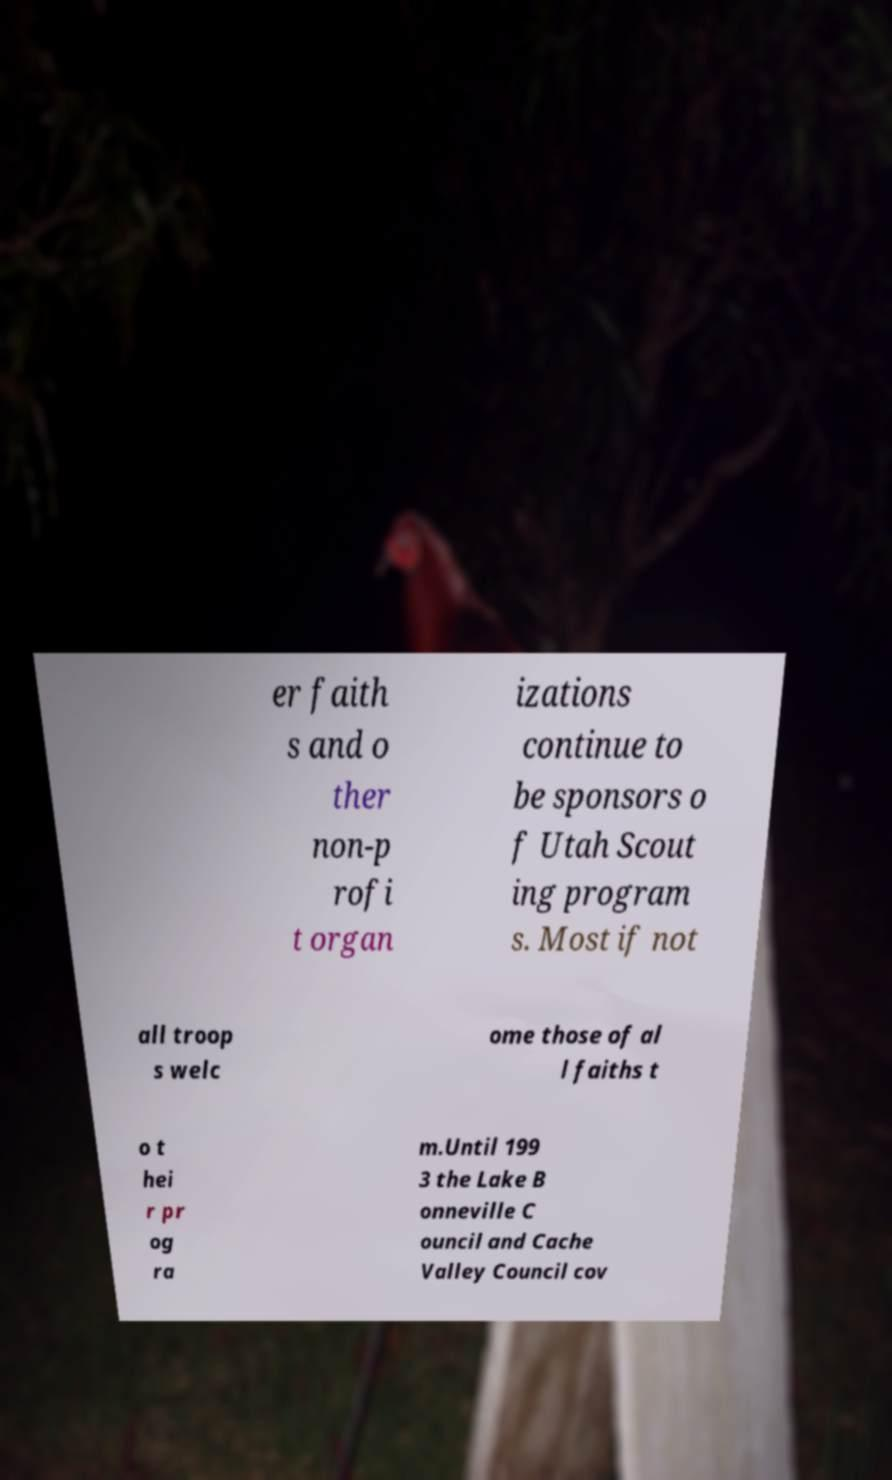Could you extract and type out the text from this image? er faith s and o ther non-p rofi t organ izations continue to be sponsors o f Utah Scout ing program s. Most if not all troop s welc ome those of al l faiths t o t hei r pr og ra m.Until 199 3 the Lake B onneville C ouncil and Cache Valley Council cov 